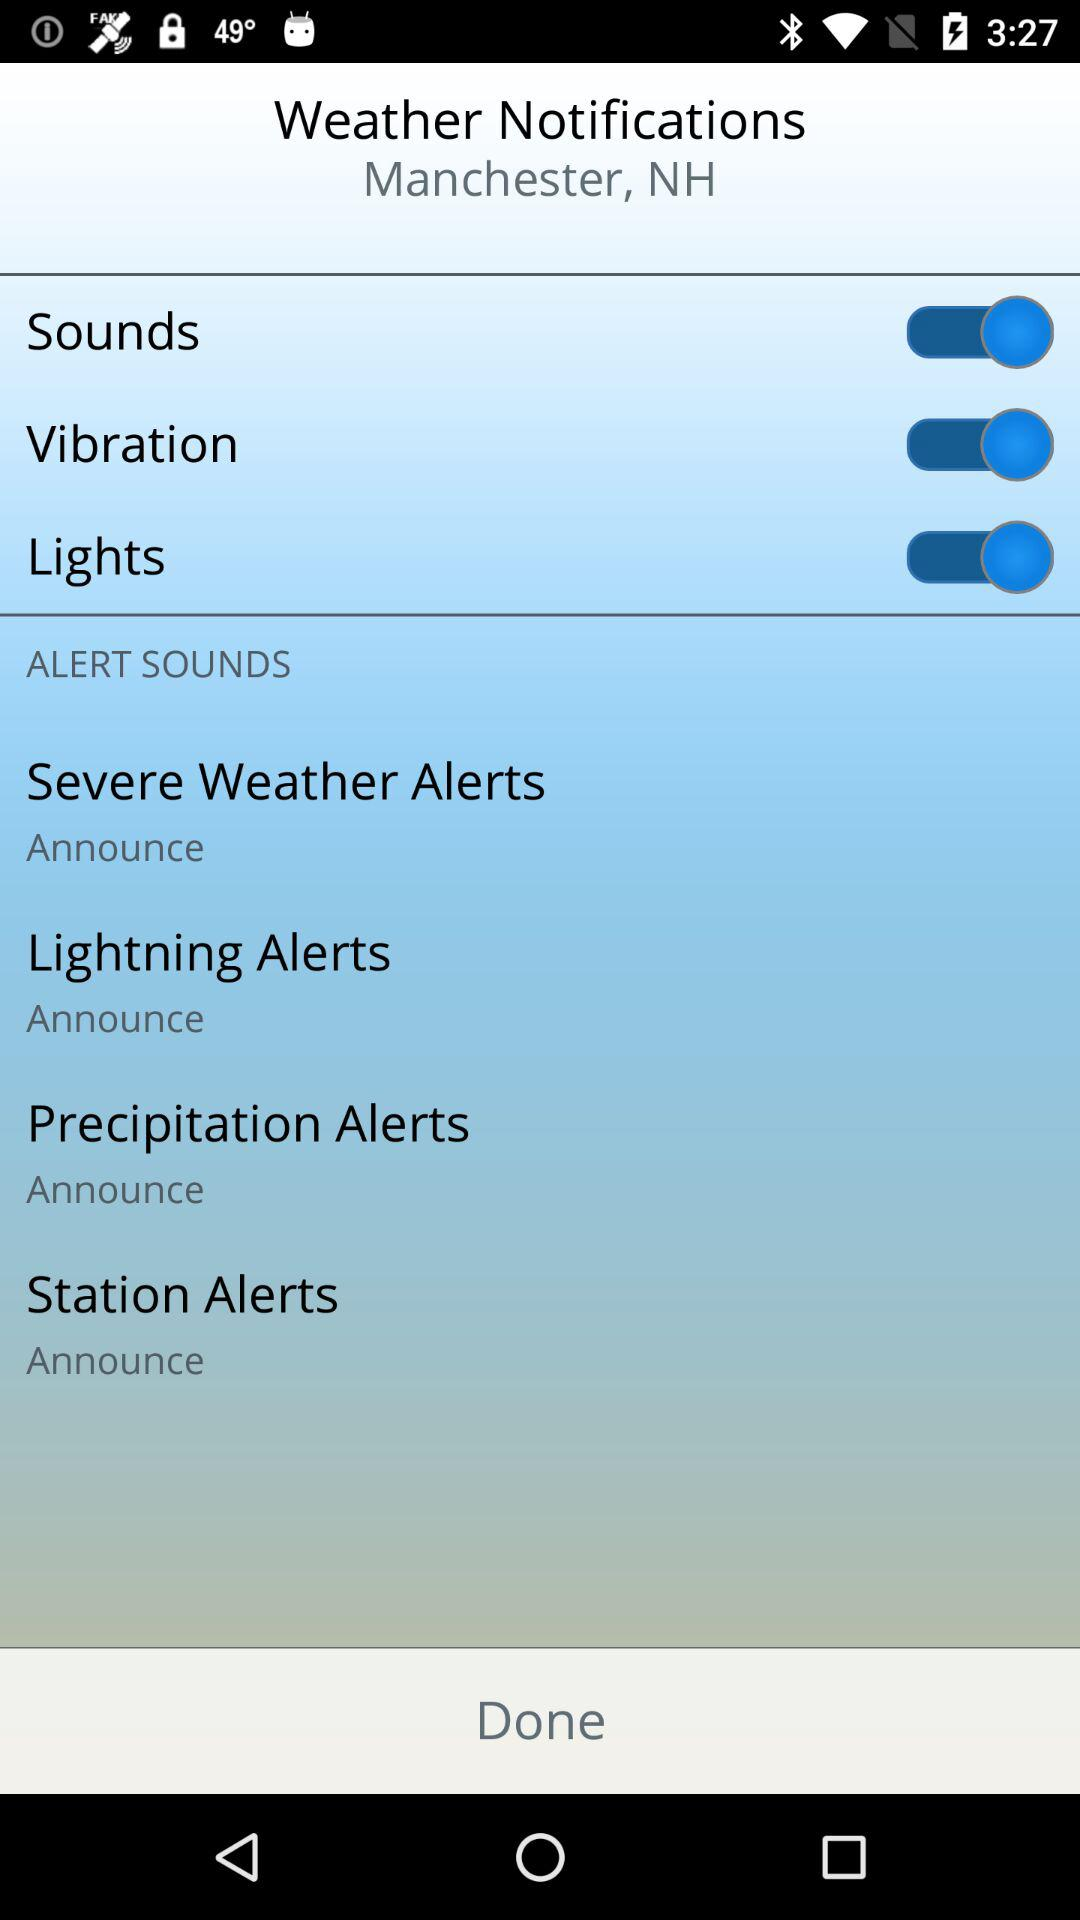What is the status of "Vibration"? The status of "Vibration" is "on". 